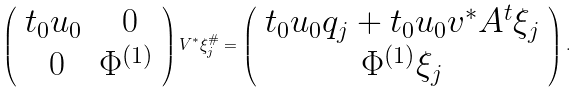<formula> <loc_0><loc_0><loc_500><loc_500>\left ( \begin{array} { c c } t _ { 0 } u _ { 0 } & \ 0 \\ \ 0 & \Phi ^ { ( 1 ) } \end{array} \right ) V ^ { * } \xi ^ { \# } _ { j } = \left ( \begin{array} { c } t _ { 0 } u _ { 0 } q _ { j } + t _ { 0 } u _ { 0 } v ^ { * } A ^ { t } \xi _ { j } \\ \Phi ^ { ( 1 ) } \xi _ { j } \end{array} \right ) .</formula> 